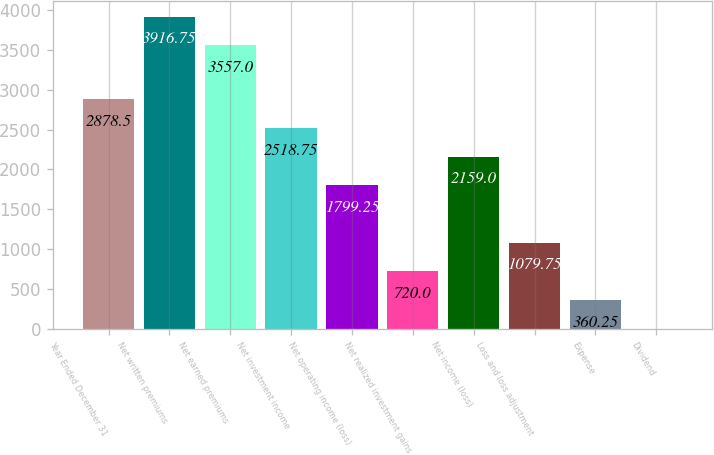Convert chart to OTSL. <chart><loc_0><loc_0><loc_500><loc_500><bar_chart><fcel>Year Ended December 31<fcel>Net written premiums<fcel>Net earned premiums<fcel>Net investment income<fcel>Net operating income (loss)<fcel>Net realized investment gains<fcel>Net income (loss)<fcel>Loss and loss adjustment<fcel>Expense<fcel>Dividend<nl><fcel>2878.5<fcel>3916.75<fcel>3557<fcel>2518.75<fcel>1799.25<fcel>720<fcel>2159<fcel>1079.75<fcel>360.25<fcel>0.5<nl></chart> 